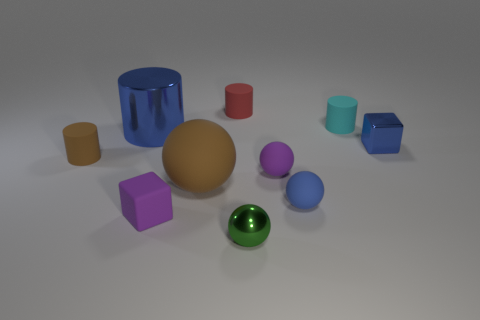Subtract all blocks. How many objects are left? 8 Subtract all small blue shiny blocks. Subtract all tiny yellow metal cylinders. How many objects are left? 9 Add 7 purple rubber cubes. How many purple rubber cubes are left? 8 Add 1 small purple shiny balls. How many small purple shiny balls exist? 1 Subtract 1 purple spheres. How many objects are left? 9 